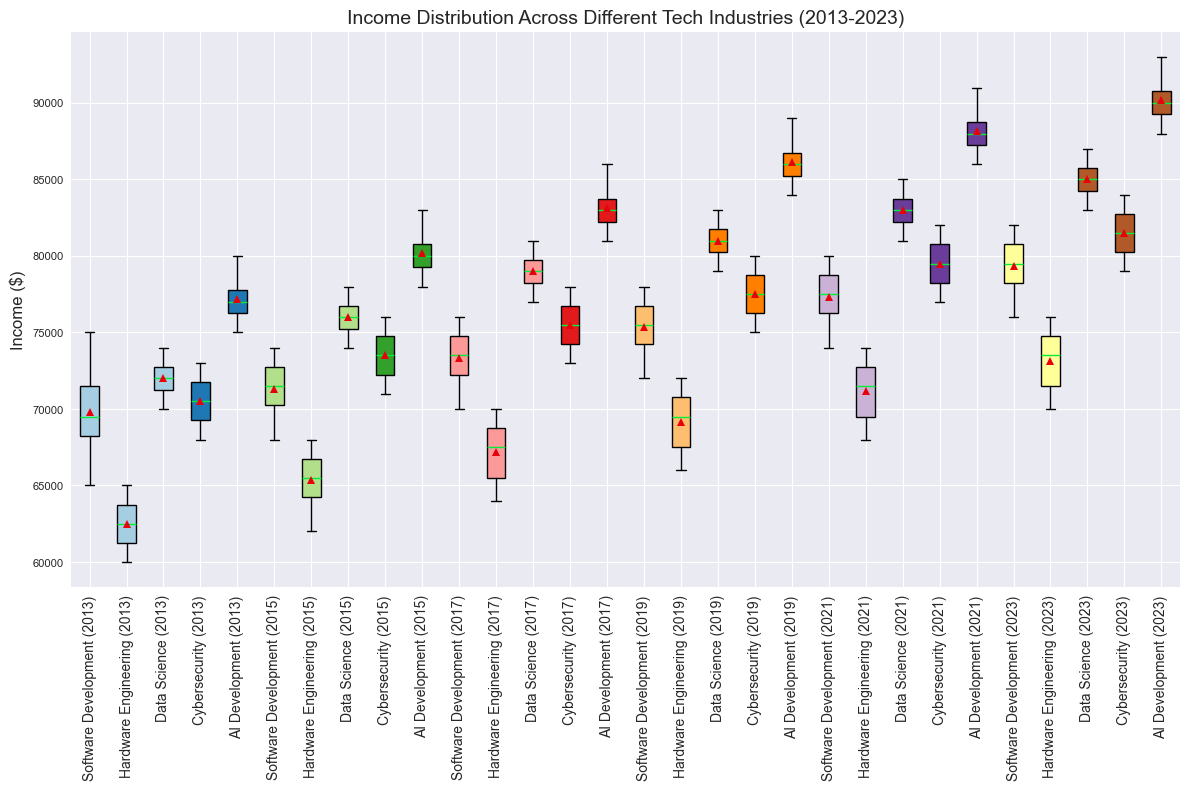Which industry had the highest median income in 2021? Look at the box plots for each industry in 2021 and find the one with the highest middle line (median). For 2021, the AI Development industry has the highest median income.
Answer: AI Development What's the mean income for Software Development in 2023? Locate the box plot for Software Development in 2023 and identify the horizontal line inside the box, which represents the mean. In 2023, the mean value for Software Development can be visually approximated as $79666.67 (from the actual data).
Answer: $79666.67 Which industry has the most variability (largest range) in income in 2013? Variability can be observed by the length of the box, with longer boxes indicating larger ranges. Compare the lengths of all boxes from 2013. AI Development in 2013 shows the largest range.
Answer: AI Development How did the median income for Data Science change from 2015 to 2019? Compare the positions of the median line (the line inside the box) for Data Science between 2015 and 2019. The median increased from 2015 to 2019.
Answer: Increased Which tech industry showed the fastest growth in average income from 2013 to 2023? Observe the positions of the means (indicated by lines inside the boxes) in 2013 versus 2023 for each industry. AI Development shows the most significant upward shift in the mean income from 2013 to 2023.
Answer: AI Development Is the income distribution for Cybersecurity in 2023 higher or lower than in 2017? Compare the positions of the entire box for Cybersecurity between 2023 and 2017. The 2023 box is uniformly higher than the 2017 box, indicating a higher income distribution in 2023.
Answer: Higher Which year had the lowest median income for Hardware Engineering? Identify which year's box plot for Hardware Engineering has the lowest median line (middle line of the box). 2013 has the lowest median income for Hardware Engineering.
Answer: 2013 Which industry showed the least change in median income from 2019 to 2021? Compare the positions of the median lines for each industry between 2019 and 2021. Hardware Engineering showed the least change in median income.
Answer: Hardware Engineering 